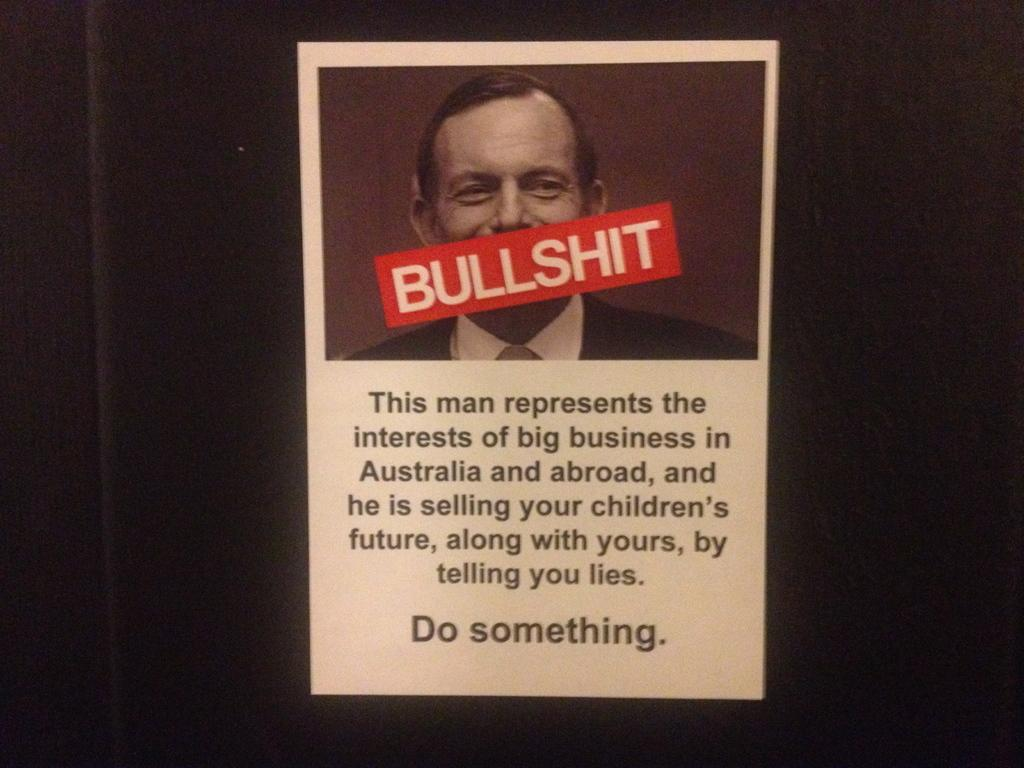What is depicted on the poster in the image? The poster features a person. What is the poster attached to? The poster is on a black object. Is there any text on the poster? Yes, there is writing on the poster. Is there any blood dripping from the person on the poster? There is no blood visible on the person or the poster in the image. What type of honey is being used to create the poster? The poster is not made of honey, and there is no honey present in the image. 